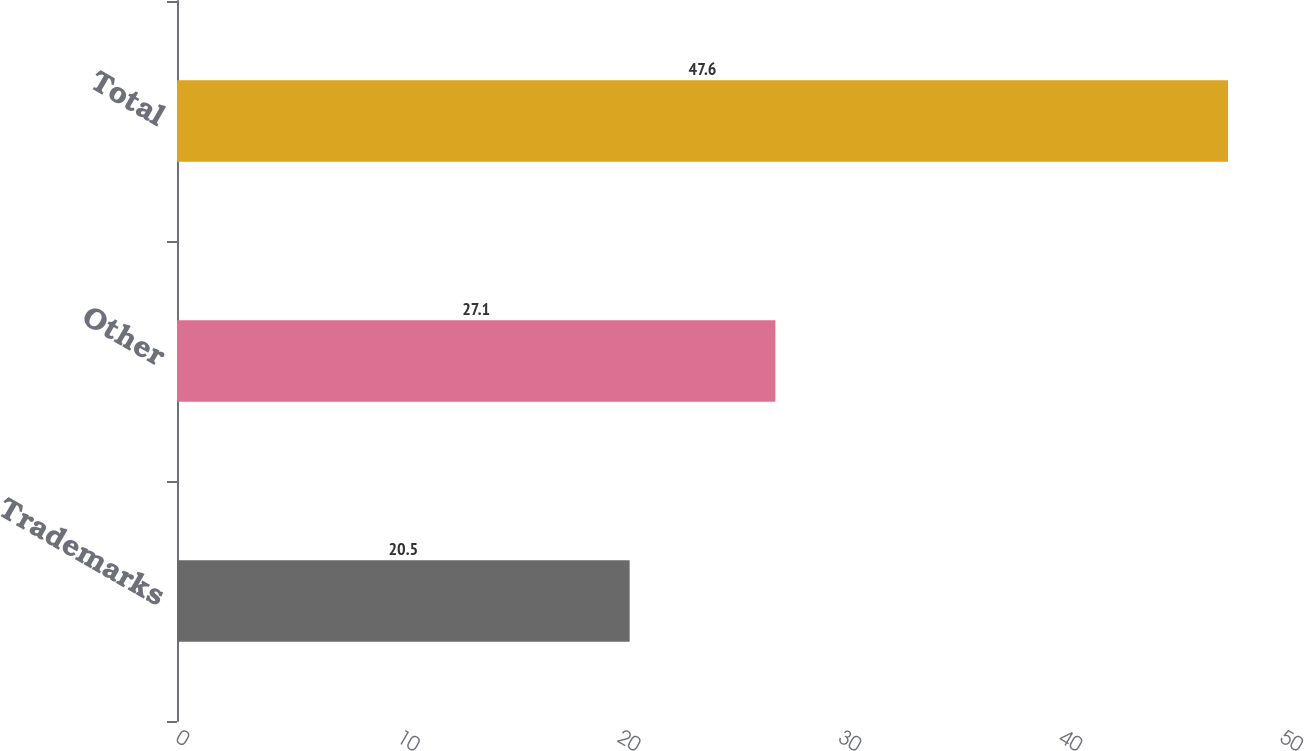<chart> <loc_0><loc_0><loc_500><loc_500><bar_chart><fcel>Trademarks<fcel>Other<fcel>Total<nl><fcel>20.5<fcel>27.1<fcel>47.6<nl></chart> 